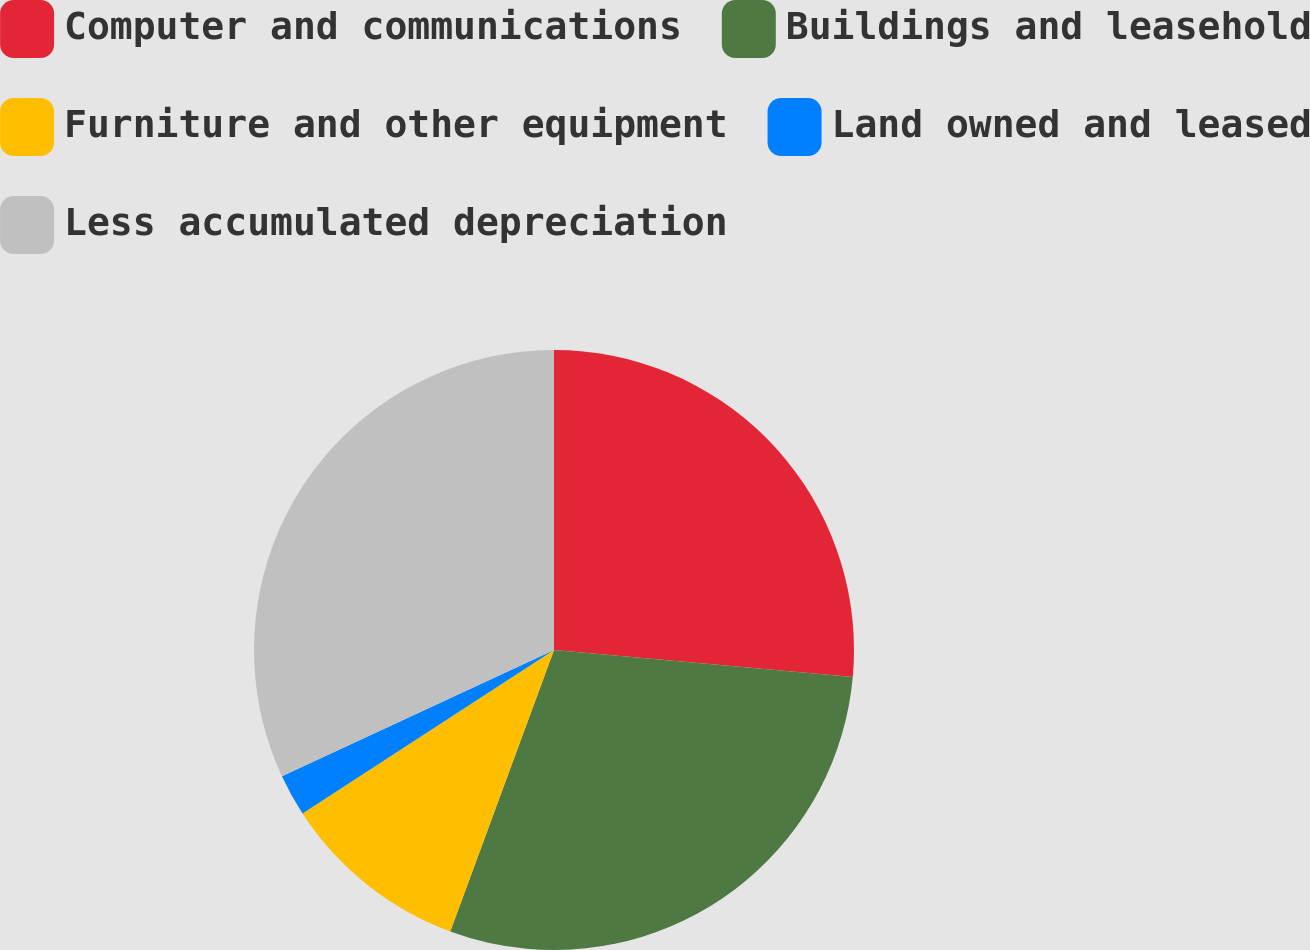Convert chart. <chart><loc_0><loc_0><loc_500><loc_500><pie_chart><fcel>Computer and communications<fcel>Buildings and leasehold<fcel>Furniture and other equipment<fcel>Land owned and leased<fcel>Less accumulated depreciation<nl><fcel>26.44%<fcel>29.18%<fcel>10.2%<fcel>2.26%<fcel>31.92%<nl></chart> 